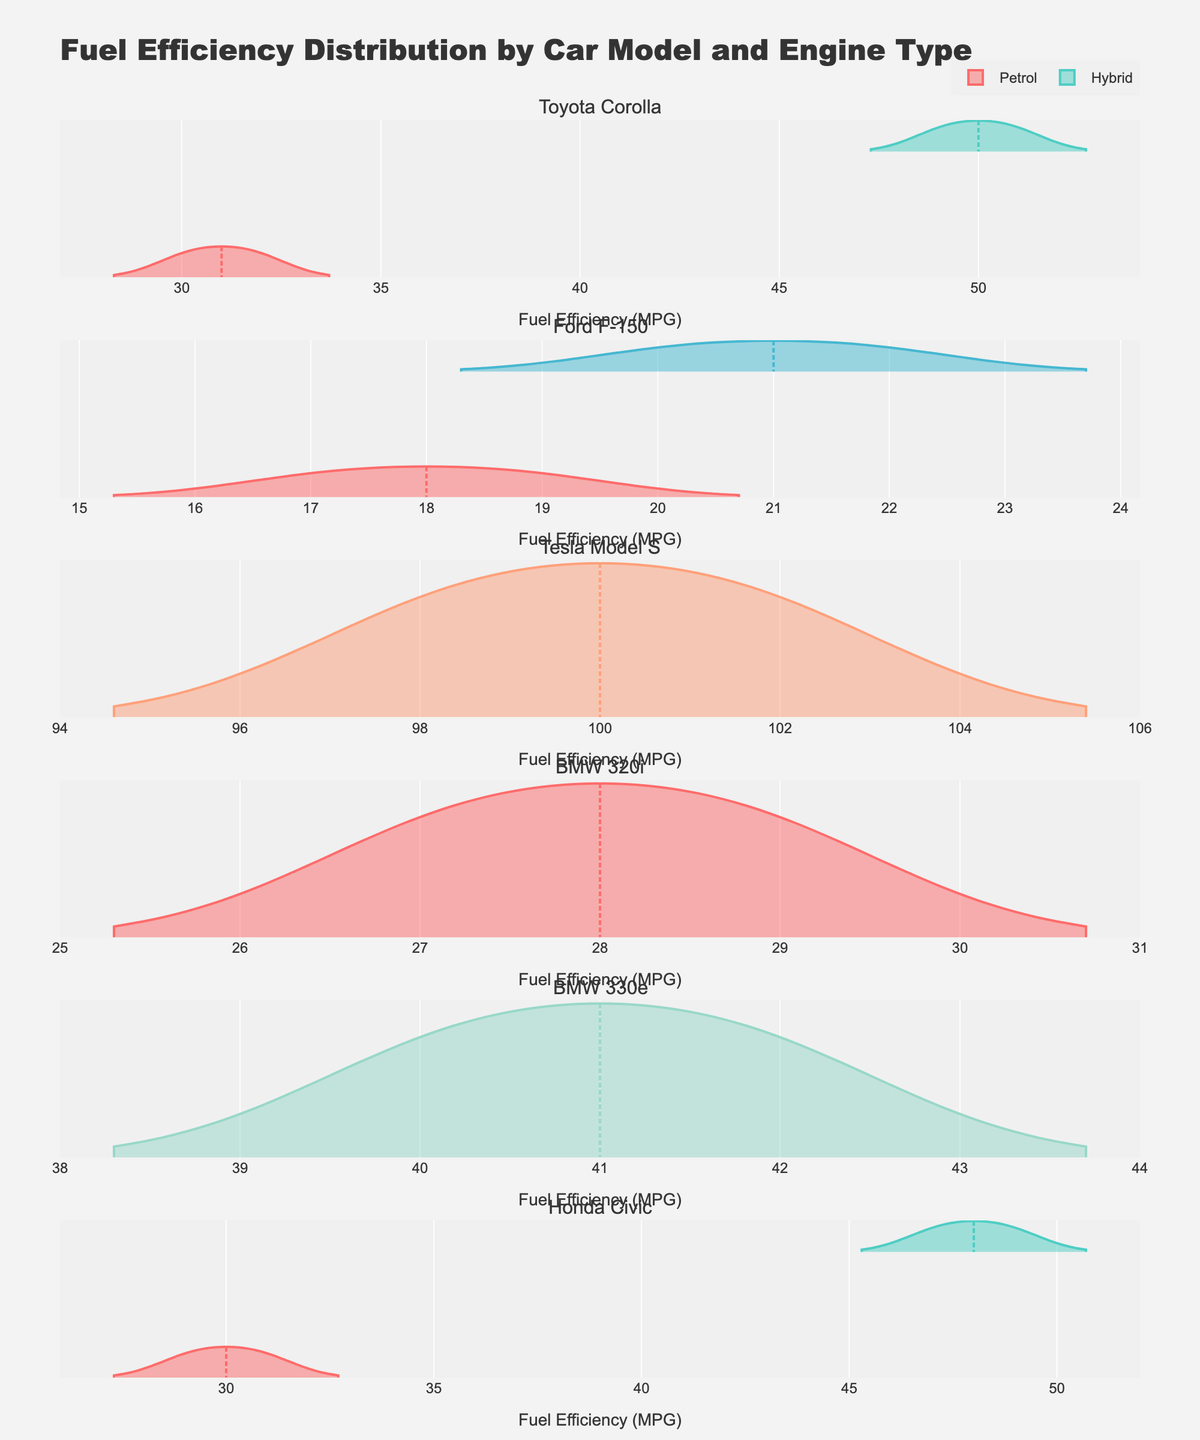Which car model has the highest fuel efficiency on average? Looking at the plot, observe the violin distributions and mean lines representing the average fuel efficiency for each car model. Tesla Model S notably has the highest average fuel efficiency as indicated by its position around 100 MPG.
Answer: Tesla Model S How does the fuel efficiency of hybrid Toyota Corolla compare to petrol Toyota Corolla? Examine the violin plots for the Toyota Corolla. The hybrid engine type shows significantly higher fuel efficiency, with figures around 50 MPG, compared to the petrol engine type which ranges around 30-32 MPG.
Answer: Hybrid is more efficient Which engine type has the widest range of fuel efficiency values for Ford F-150? Check the spread of the data within the violin plots for Ford F-150. The diesel engine type shows a wider range, spanning from 20 to 22 MPG compared to the petrol engine type, which ranges from 17 to 19 MPG.
Answer: Diesel Does any model present overlapping fuel efficiency values across different engine types? Look for areas within the violin plots where values of different engine types overlap. The Toyota Corolla does not show overlapping as the hybrid and petrol distributions are distinct. Similarly, other models also have clear separation between engine types.
Answer: No What is the most notable feature of the Tesla Model S in terms of fuel efficiency? Observe the violin plot for Tesla Model S. Its distribution is the highest across all models and engine types, centered around 100 MPG, with a range that slightly varies around this high mean value.
Answer: Highest fuel efficiency Is the fuel efficiency of electric vehicles higher than other engine types? Compare the electric vehicle (Tesla Model S) with other engine types. The electric vehicle shows much higher fuel efficiency, around 100 MPG, compared to other engine types which range between 17-51 MPG.
Answer: Yes Which model has the most consistent fuel efficiency across its engine types? Identify the models with minimal spread in their violin plots. The Ford F-150, particularly with its diesel engine, exhibits little variability ranging from 20-22 MPG, indicating consistent performance.
Answer: Ford F-150 (Diesel) Among hybrid vehicles, which model has the highest fuel efficiency? Compare the violin plots for the hybrid versions of the Toyota Corolla and the Honda Civic. Both have high fuel efficiency, but the Toyota Corolla slightly exceeds the Civic with ranges around 49-51 MPG compared to Civic's 47-49 MPG.
Answer: Toyota Corolla What notable difference exists between the Plug-in Hybrid and Petrol engine types for BMW models? Examine the BMW 320i (petrol) and BMW 330e (plug-in hybrid) violin plots. The plug-in hybrid shows significantly higher fuel efficiency, around 40-42 MPG, compared to the petrol engine's 27-29 MPG.
Answer: Plug-in Hybrid has higher efficiency How does the average fuel efficiency of Toyota Corolla compare to Ford F-150? Check the mean line indicators within the violin plots for Toyota Corolla and Ford F-150. Toyota Corolla, both hybrid, and petrol versions have higher averages around 30-50 MPG, whereas Ford F-150 shows lower averages around 17-22 MPG.
Answer: Toyota Corolla is more efficient 